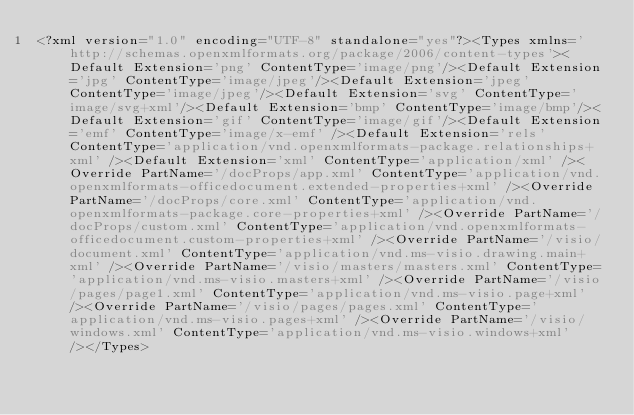Convert code to text. <code><loc_0><loc_0><loc_500><loc_500><_XML_><?xml version="1.0" encoding="UTF-8" standalone="yes"?><Types xmlns='http://schemas.openxmlformats.org/package/2006/content-types'><Default Extension='png' ContentType='image/png'/><Default Extension='jpg' ContentType='image/jpeg'/><Default Extension='jpeg' ContentType='image/jpeg'/><Default Extension='svg' ContentType='image/svg+xml'/><Default Extension='bmp' ContentType='image/bmp'/><Default Extension='gif' ContentType='image/gif'/><Default Extension='emf' ContentType='image/x-emf' /><Default Extension='rels' ContentType='application/vnd.openxmlformats-package.relationships+xml' /><Default Extension='xml' ContentType='application/xml' /><Override PartName='/docProps/app.xml' ContentType='application/vnd.openxmlformats-officedocument.extended-properties+xml' /><Override PartName='/docProps/core.xml' ContentType='application/vnd.openxmlformats-package.core-properties+xml' /><Override PartName='/docProps/custom.xml' ContentType='application/vnd.openxmlformats-officedocument.custom-properties+xml' /><Override PartName='/visio/document.xml' ContentType='application/vnd.ms-visio.drawing.main+xml' /><Override PartName='/visio/masters/masters.xml' ContentType='application/vnd.ms-visio.masters+xml' /><Override PartName='/visio/pages/page1.xml' ContentType='application/vnd.ms-visio.page+xml' /><Override PartName='/visio/pages/pages.xml' ContentType='application/vnd.ms-visio.pages+xml' /><Override PartName='/visio/windows.xml' ContentType='application/vnd.ms-visio.windows+xml' /></Types></code> 